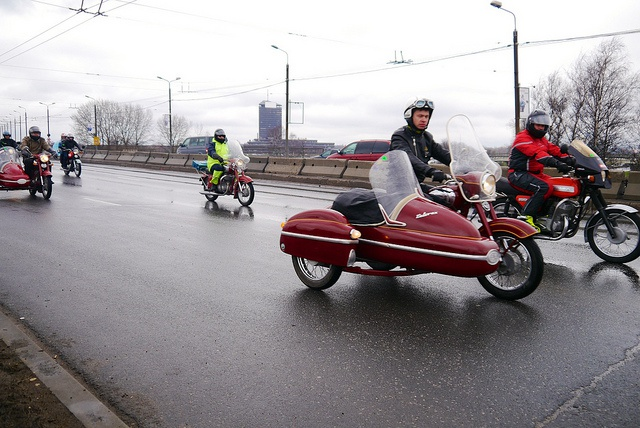Describe the objects in this image and their specific colors. I can see motorcycle in lightgray, black, gray, darkgray, and brown tones, motorcycle in lightgray, black, darkgray, and gray tones, people in lightgray, black, brown, and maroon tones, people in lightgray, black, gray, and brown tones, and motorcycle in lightgray, black, darkgray, and gray tones in this image. 